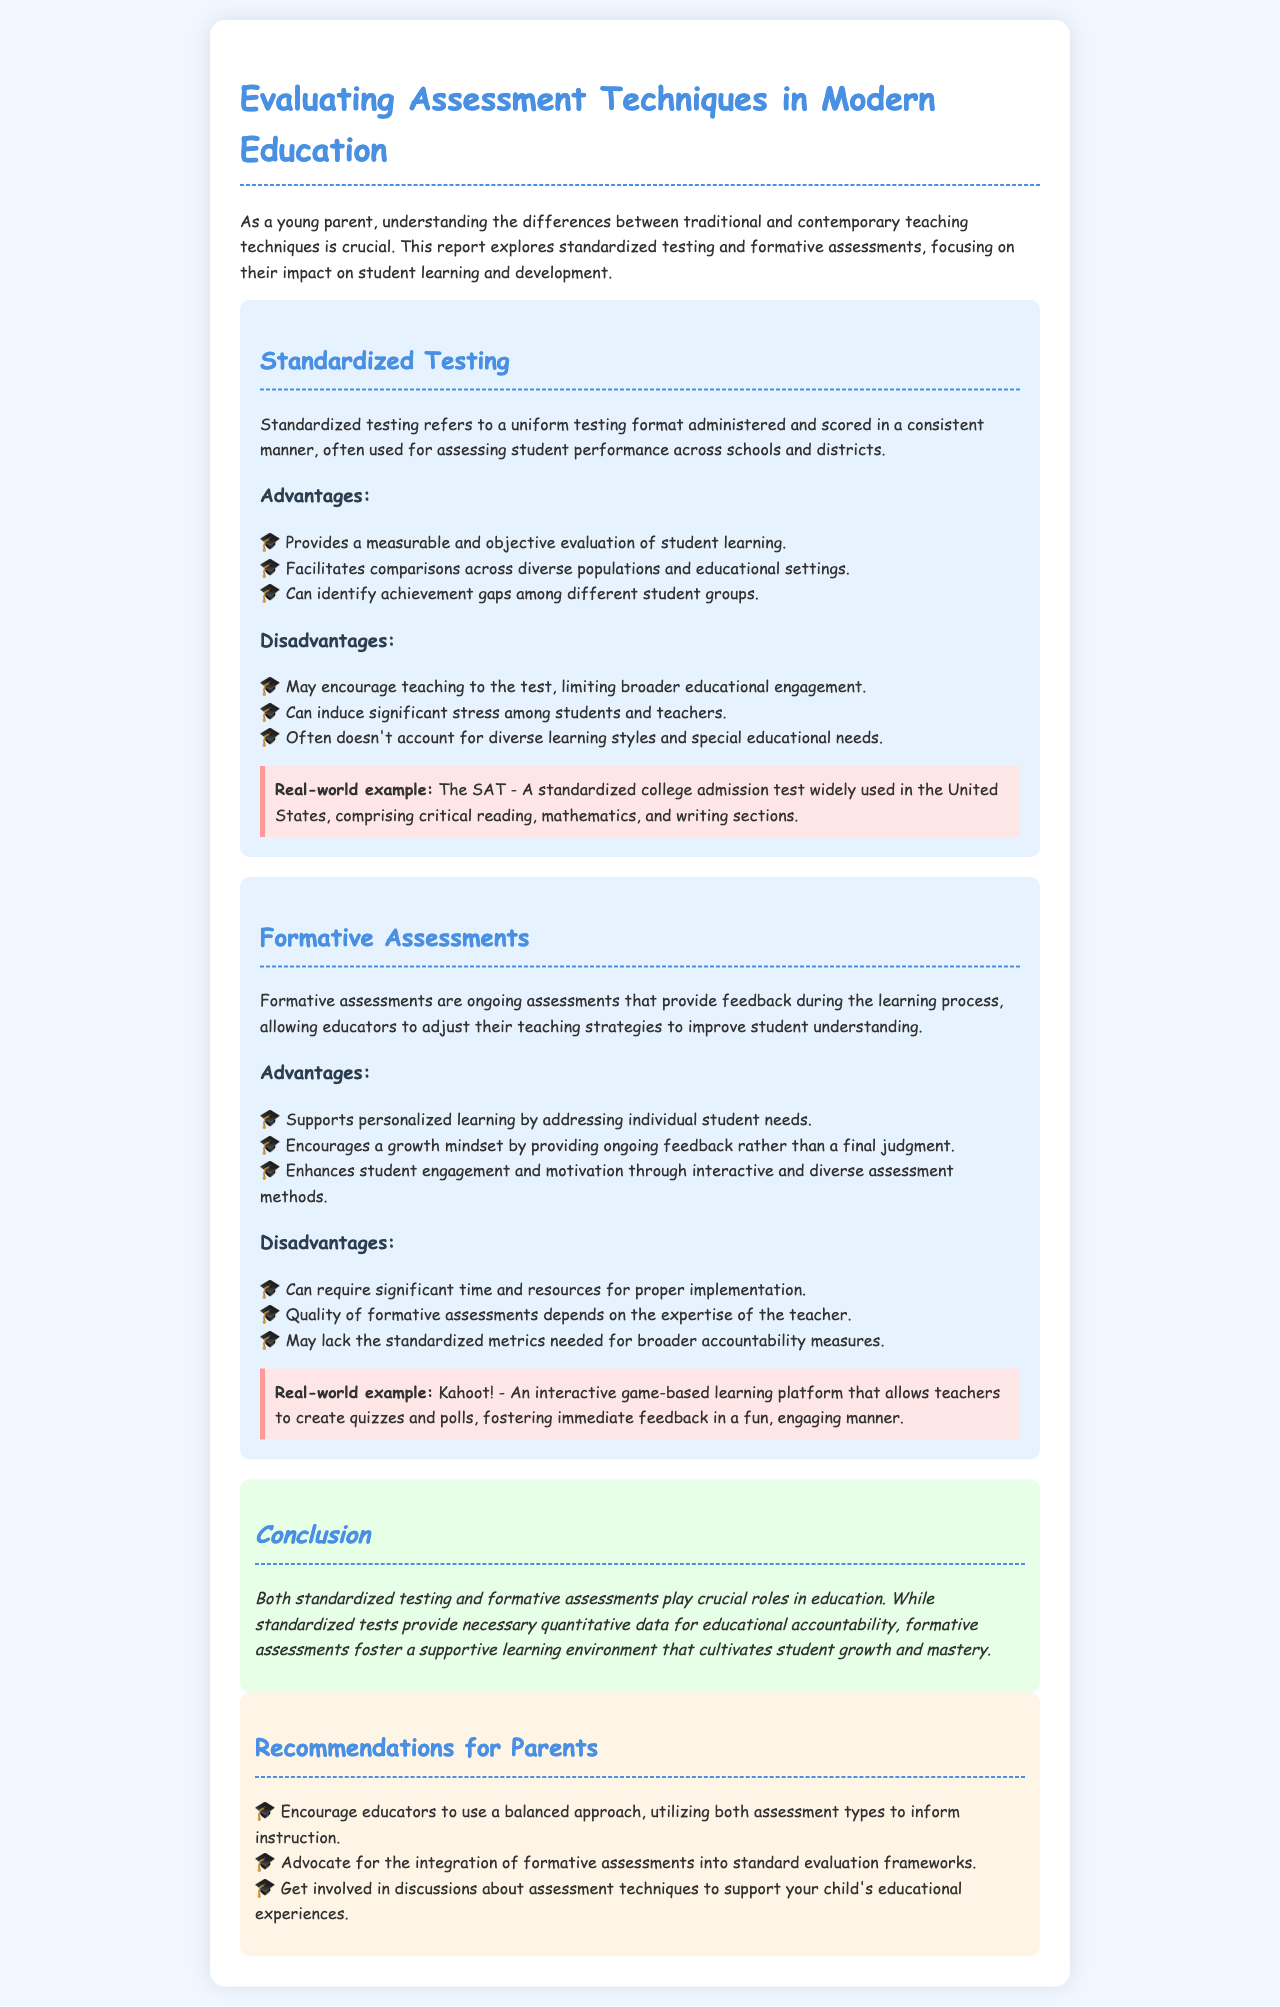What is the title of the report? The title is stated prominently at the beginning of the document.
Answer: Evaluating Assessment Techniques in Modern Education What type of assessments provide ongoing feedback? This information is found in the section discussing formative assessments.
Answer: Formative Assessments What is one advantage of standardized testing? Information about advantages is listed in the advantages section for standardized testing.
Answer: Provides a measurable and objective evaluation of student learning What is a disadvantage of formative assessments? The disadvantages section outlines challenges faced with formative assessments.
Answer: Can require significant time and resources for proper implementation What is a real-world example of standardized testing? The document provides an example of standardized testing in the respective section.
Answer: The SAT How do formative assessments support learning? They are described in the advantages section as encouraging a specific mindset.
Answer: Encourages a growth mindset by providing ongoing feedback What is a recommendation for parents in the document? The recommendations section outlines suggestions for parental involvement.
Answer: Encourage educators to use a balanced approach, utilizing both assessment types How does standardized testing impact student stress levels? Disadvantages mentioned indicate the emotional effects on students.
Answer: Can induce significant stress among students and teachers What is the background color of the report? The background color for the document is specified in the style section.
Answer: #f0f7ff 